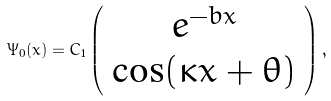Convert formula to latex. <formula><loc_0><loc_0><loc_500><loc_500>\Psi _ { 0 } ( x ) = C _ { 1 } \left ( \begin{array} { c } { { e ^ { - b x } } } \\ { \cos ( \kappa x + \theta ) } \end{array} \right ) ,</formula> 